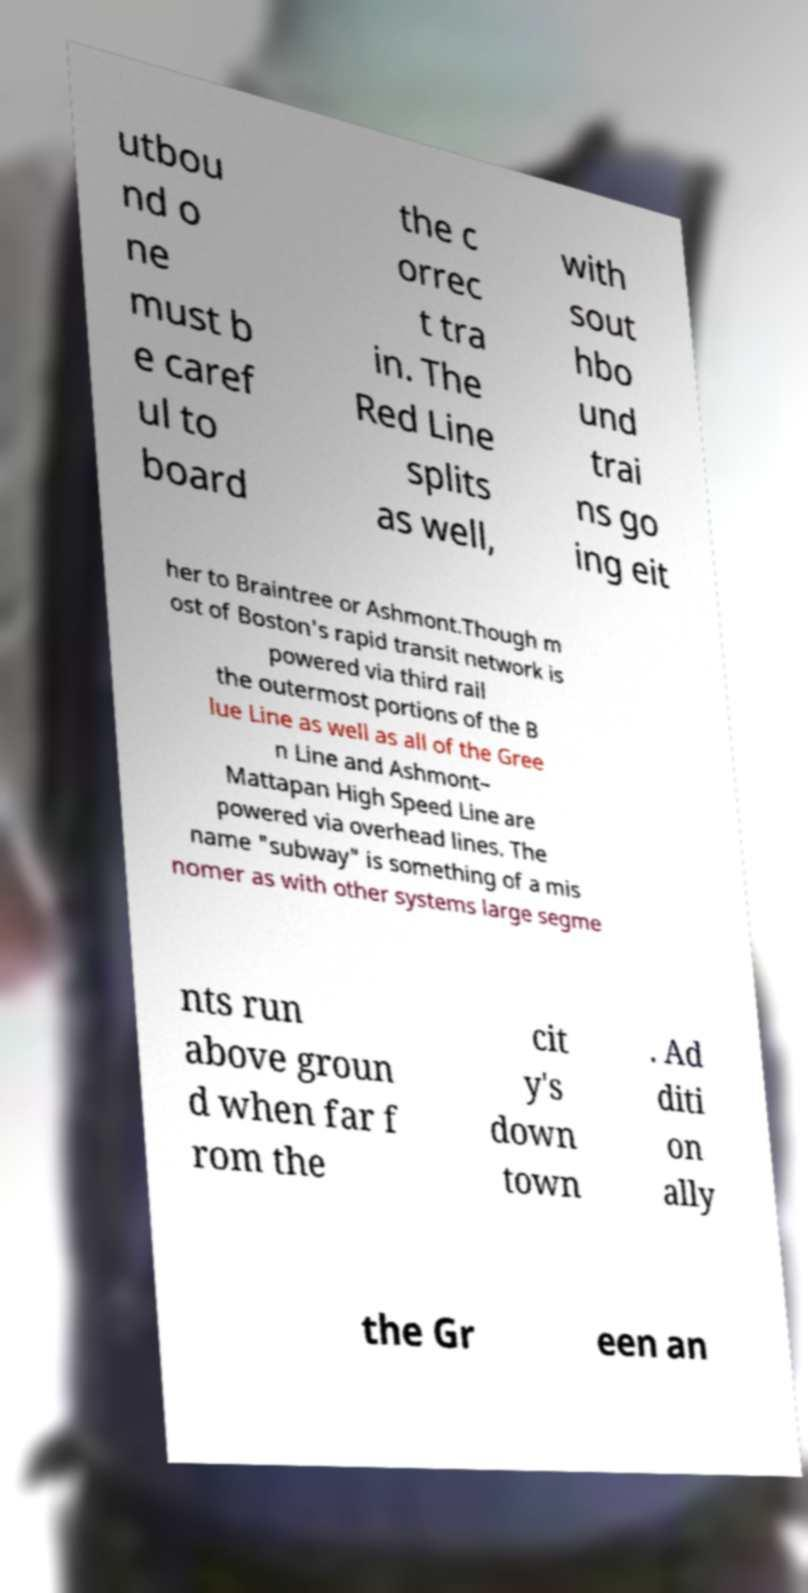What messages or text are displayed in this image? I need them in a readable, typed format. utbou nd o ne must b e caref ul to board the c orrec t tra in. The Red Line splits as well, with sout hbo und trai ns go ing eit her to Braintree or Ashmont.Though m ost of Boston's rapid transit network is powered via third rail the outermost portions of the B lue Line as well as all of the Gree n Line and Ashmont– Mattapan High Speed Line are powered via overhead lines. The name "subway" is something of a mis nomer as with other systems large segme nts run above groun d when far f rom the cit y's down town . Ad diti on ally the Gr een an 